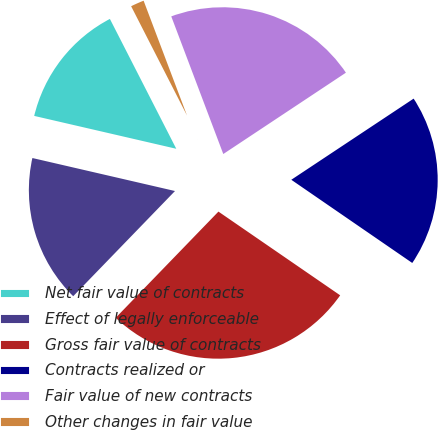<chart> <loc_0><loc_0><loc_500><loc_500><pie_chart><fcel>Net fair value of contracts<fcel>Effect of legally enforceable<fcel>Gross fair value of contracts<fcel>Contracts realized or<fcel>Fair value of new contracts<fcel>Other changes in fair value<nl><fcel>13.86%<fcel>16.38%<fcel>27.65%<fcel>18.91%<fcel>21.43%<fcel>1.77%<nl></chart> 